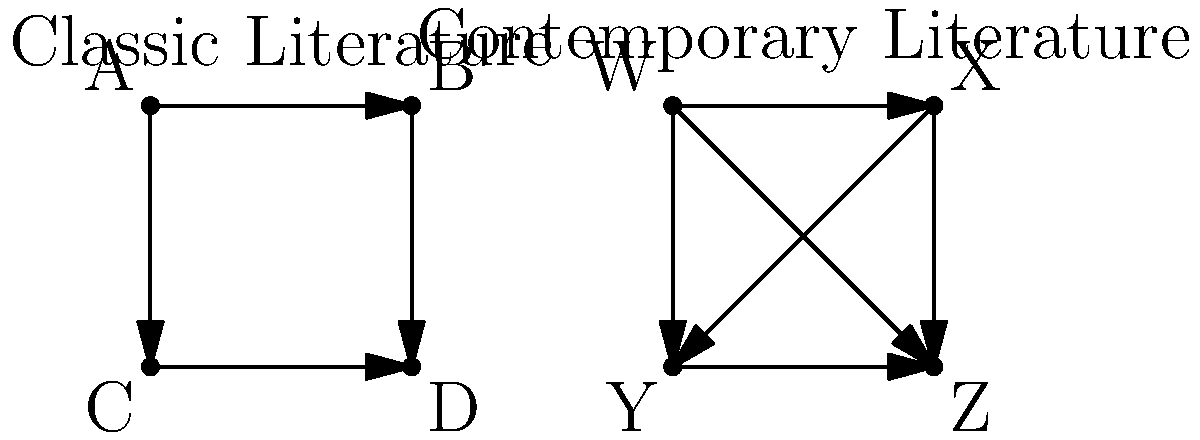Based on the network diagrams representing character relationships in classic and contemporary literature, which type of literature tends to exhibit more complex interpersonal dynamics, and how might this impact a psychologist's analysis of love and relationships in these works? To answer this question, let's analyze the network diagrams step-by-step:

1. Classic Literature Network:
   - 4 characters (A, B, C, D)
   - 4 connections (arrows)
   - Connections are unidirectional and only between adjacent characters

2. Contemporary Literature Network:
   - 4 characters (W, X, Y, Z)
   - 6 connections (arrows)
   - Connections are unidirectional but include diagonal relationships

3. Complexity comparison:
   - Contemporary literature has more connections (6 vs. 4)
   - Contemporary literature shows more diverse relationship patterns (including diagonal connections)

4. Impact on psychological analysis:
   a) Depth of relationships: Contemporary literature may offer more opportunities to explore complex, multi-faceted relationships due to the increased number of connections.
   
   b) Triangulation: The diagonal connections in contemporary literature allow for the study of triangular relationships, which can be rich sources for analyzing jealousy, loyalty, and conflict.
   
   c) Character development: With more connections, contemporary characters may exhibit more dynamic growth and change throughout the narrative.
   
   d) Societal reflection: The increased complexity in contemporary literature might reflect modern social structures and relationship dynamics, providing insight into current psychological challenges.
   
   e) Comparative analysis: Studying both networks allows for an examination of how relationship portrayals have evolved over time, potentially reflecting changes in societal norms and expectations.

5. Conclusion: Contemporary literature, as represented in the diagram, tends to exhibit more complex interpersonal dynamics. This increased complexity provides a richer field for psychological analysis of love and relationships, allowing for more nuanced interpretations and a broader range of relationship types to study.
Answer: Contemporary literature; offers more complex relationships for richer psychological analysis. 